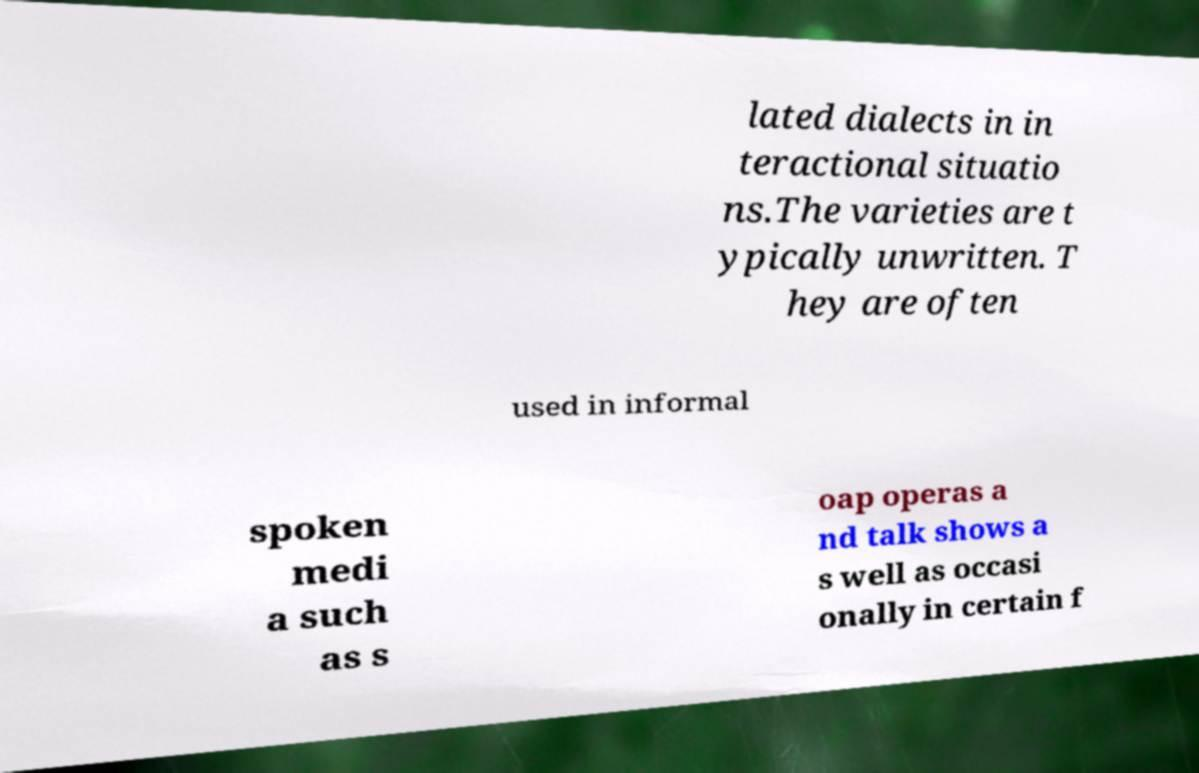I need the written content from this picture converted into text. Can you do that? lated dialects in in teractional situatio ns.The varieties are t ypically unwritten. T hey are often used in informal spoken medi a such as s oap operas a nd talk shows a s well as occasi onally in certain f 